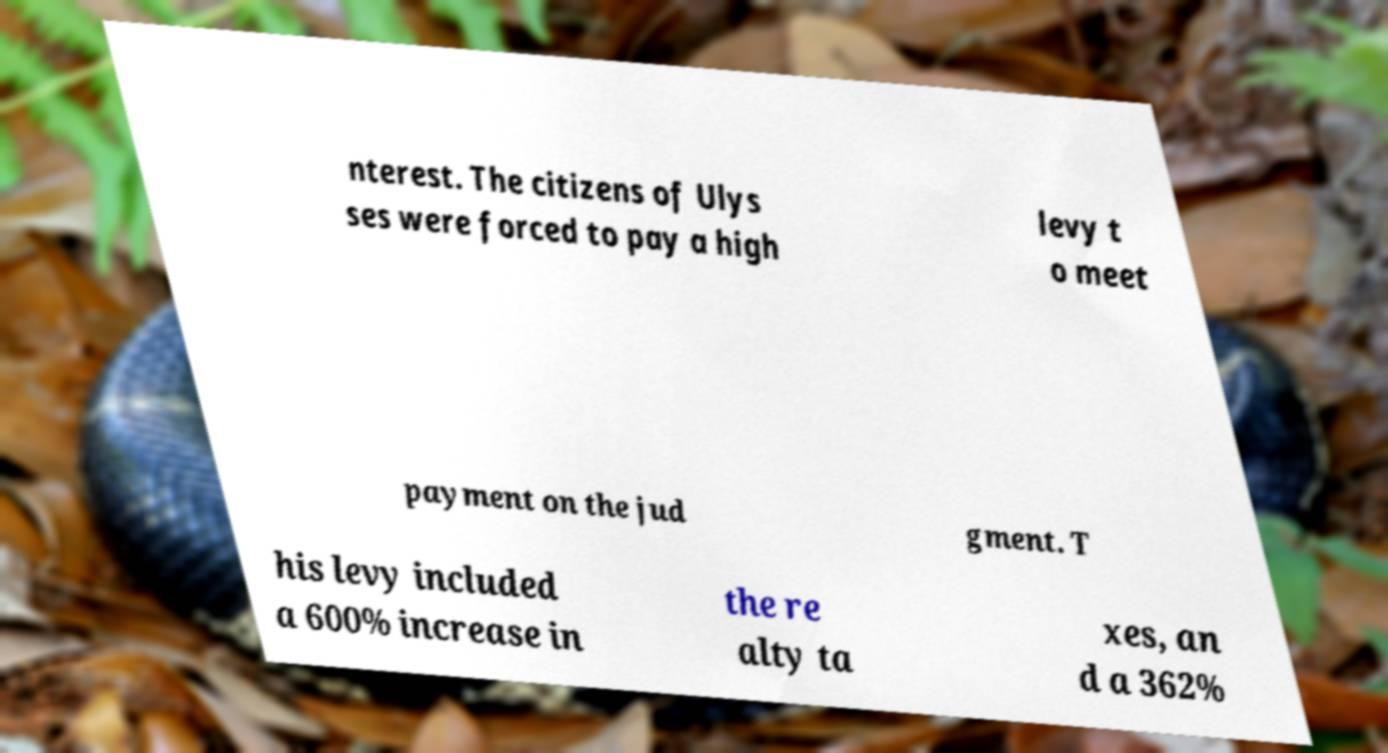Can you accurately transcribe the text from the provided image for me? nterest. The citizens of Ulys ses were forced to pay a high levy t o meet payment on the jud gment. T his levy included a 600% increase in the re alty ta xes, an d a 362% 